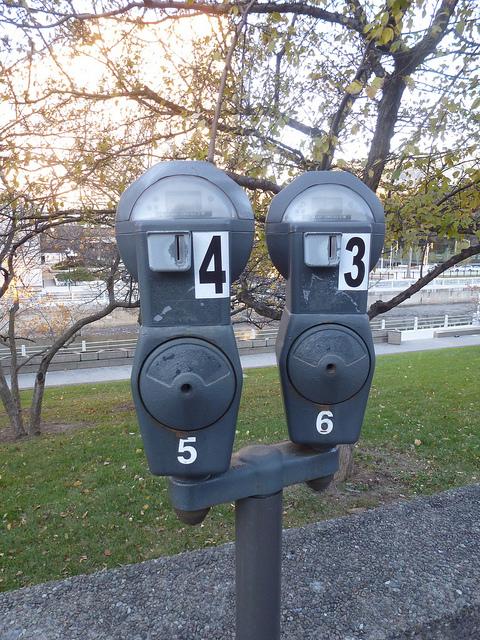Are the parking meters in use?
Answer briefly. Yes. What numbers can be seen on the meters?
Give a very brief answer. 4 3 5 6. How many parking spots are along this curb?
Quick response, please. 2. 